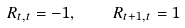Convert formula to latex. <formula><loc_0><loc_0><loc_500><loc_500>R _ { t , t } = - 1 , \quad R _ { t + 1 , t } = 1</formula> 